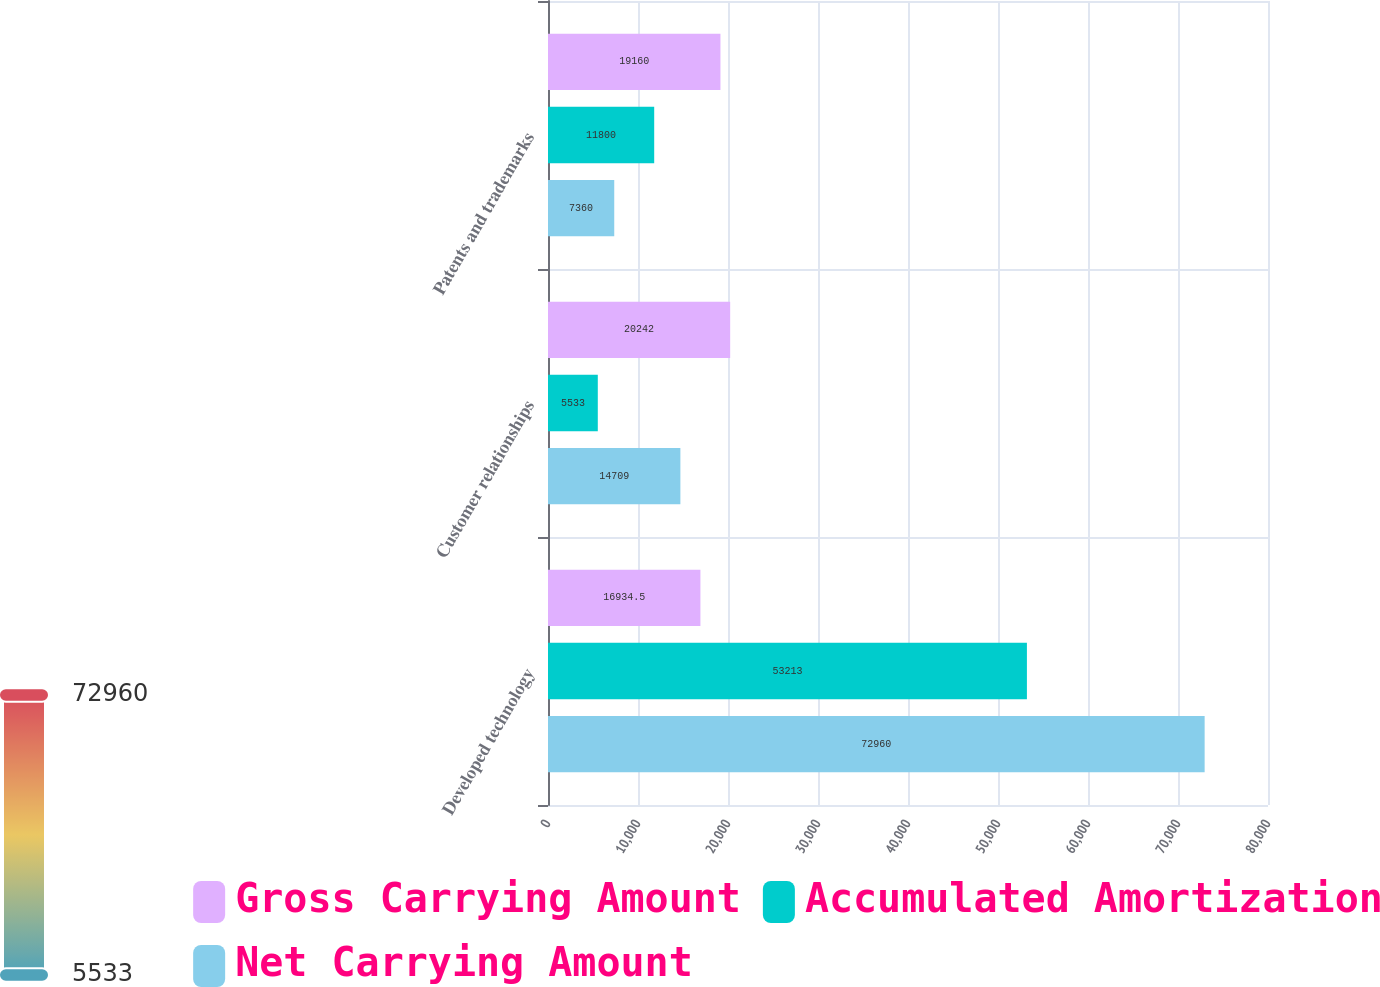Convert chart to OTSL. <chart><loc_0><loc_0><loc_500><loc_500><stacked_bar_chart><ecel><fcel>Developed technology<fcel>Customer relationships<fcel>Patents and trademarks<nl><fcel>Gross Carrying Amount<fcel>16934.5<fcel>20242<fcel>19160<nl><fcel>Accumulated Amortization<fcel>53213<fcel>5533<fcel>11800<nl><fcel>Net Carrying Amount<fcel>72960<fcel>14709<fcel>7360<nl></chart> 